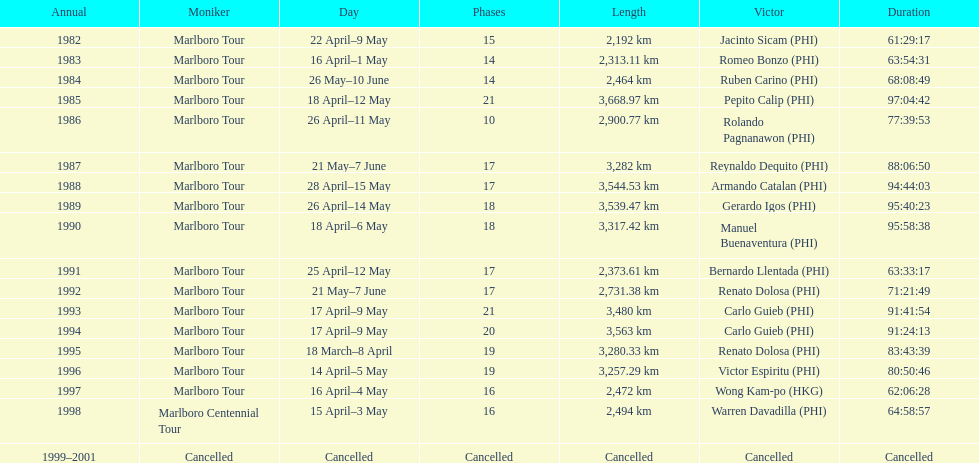Who won the most marlboro tours? Carlo Guieb. 